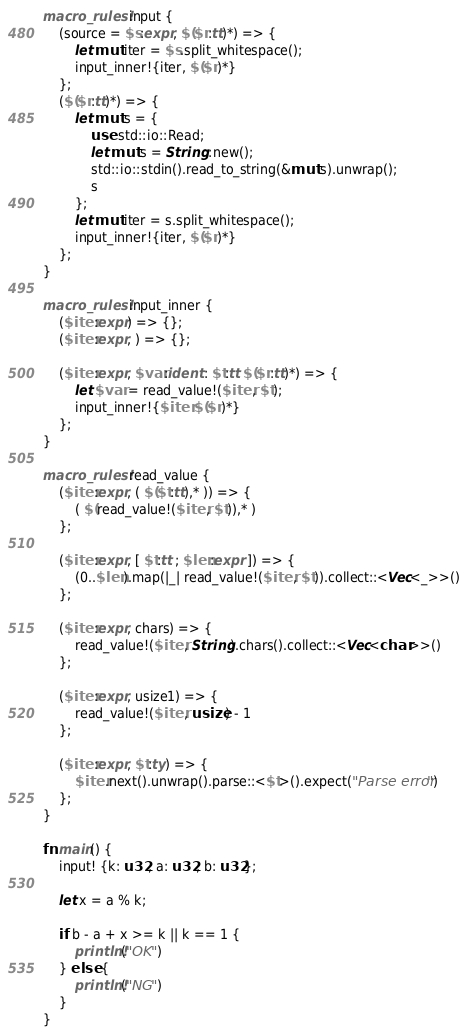<code> <loc_0><loc_0><loc_500><loc_500><_Rust_>macro_rules! input {
    (source = $s:expr, $($r:tt)*) => {
        let mut iter = $s.split_whitespace();
        input_inner!{iter, $($r)*}
    };
    ($($r:tt)*) => {
        let mut s = {
            use std::io::Read;
            let mut s = String::new();
            std::io::stdin().read_to_string(&mut s).unwrap();
            s
        };
        let mut iter = s.split_whitespace();
        input_inner!{iter, $($r)*}
    };
}

macro_rules! input_inner {
    ($iter:expr) => {};
    ($iter:expr, ) => {};

    ($iter:expr, $var:ident : $t:tt $($r:tt)*) => {
        let $var = read_value!($iter, $t);
        input_inner!{$iter $($r)*}
    };
}

macro_rules! read_value {
    ($iter:expr, ( $($t:tt),* )) => {
        ( $(read_value!($iter, $t)),* )
    };

    ($iter:expr, [ $t:tt ; $len:expr ]) => {
        (0..$len).map(|_| read_value!($iter, $t)).collect::<Vec<_>>()
    };

    ($iter:expr, chars) => {
        read_value!($iter, String).chars().collect::<Vec<char>>()
    };

    ($iter:expr, usize1) => {
        read_value!($iter, usize) - 1
    };

    ($iter:expr, $t:ty) => {
        $iter.next().unwrap().parse::<$t>().expect("Parse error")
    };
}

fn main() {
    input! {k: u32, a: u32, b: u32};

    let x = a % k;

    if b - a + x >= k || k == 1 {
        println!("OK")
    } else {
        println!("NG")
    }
}
</code> 